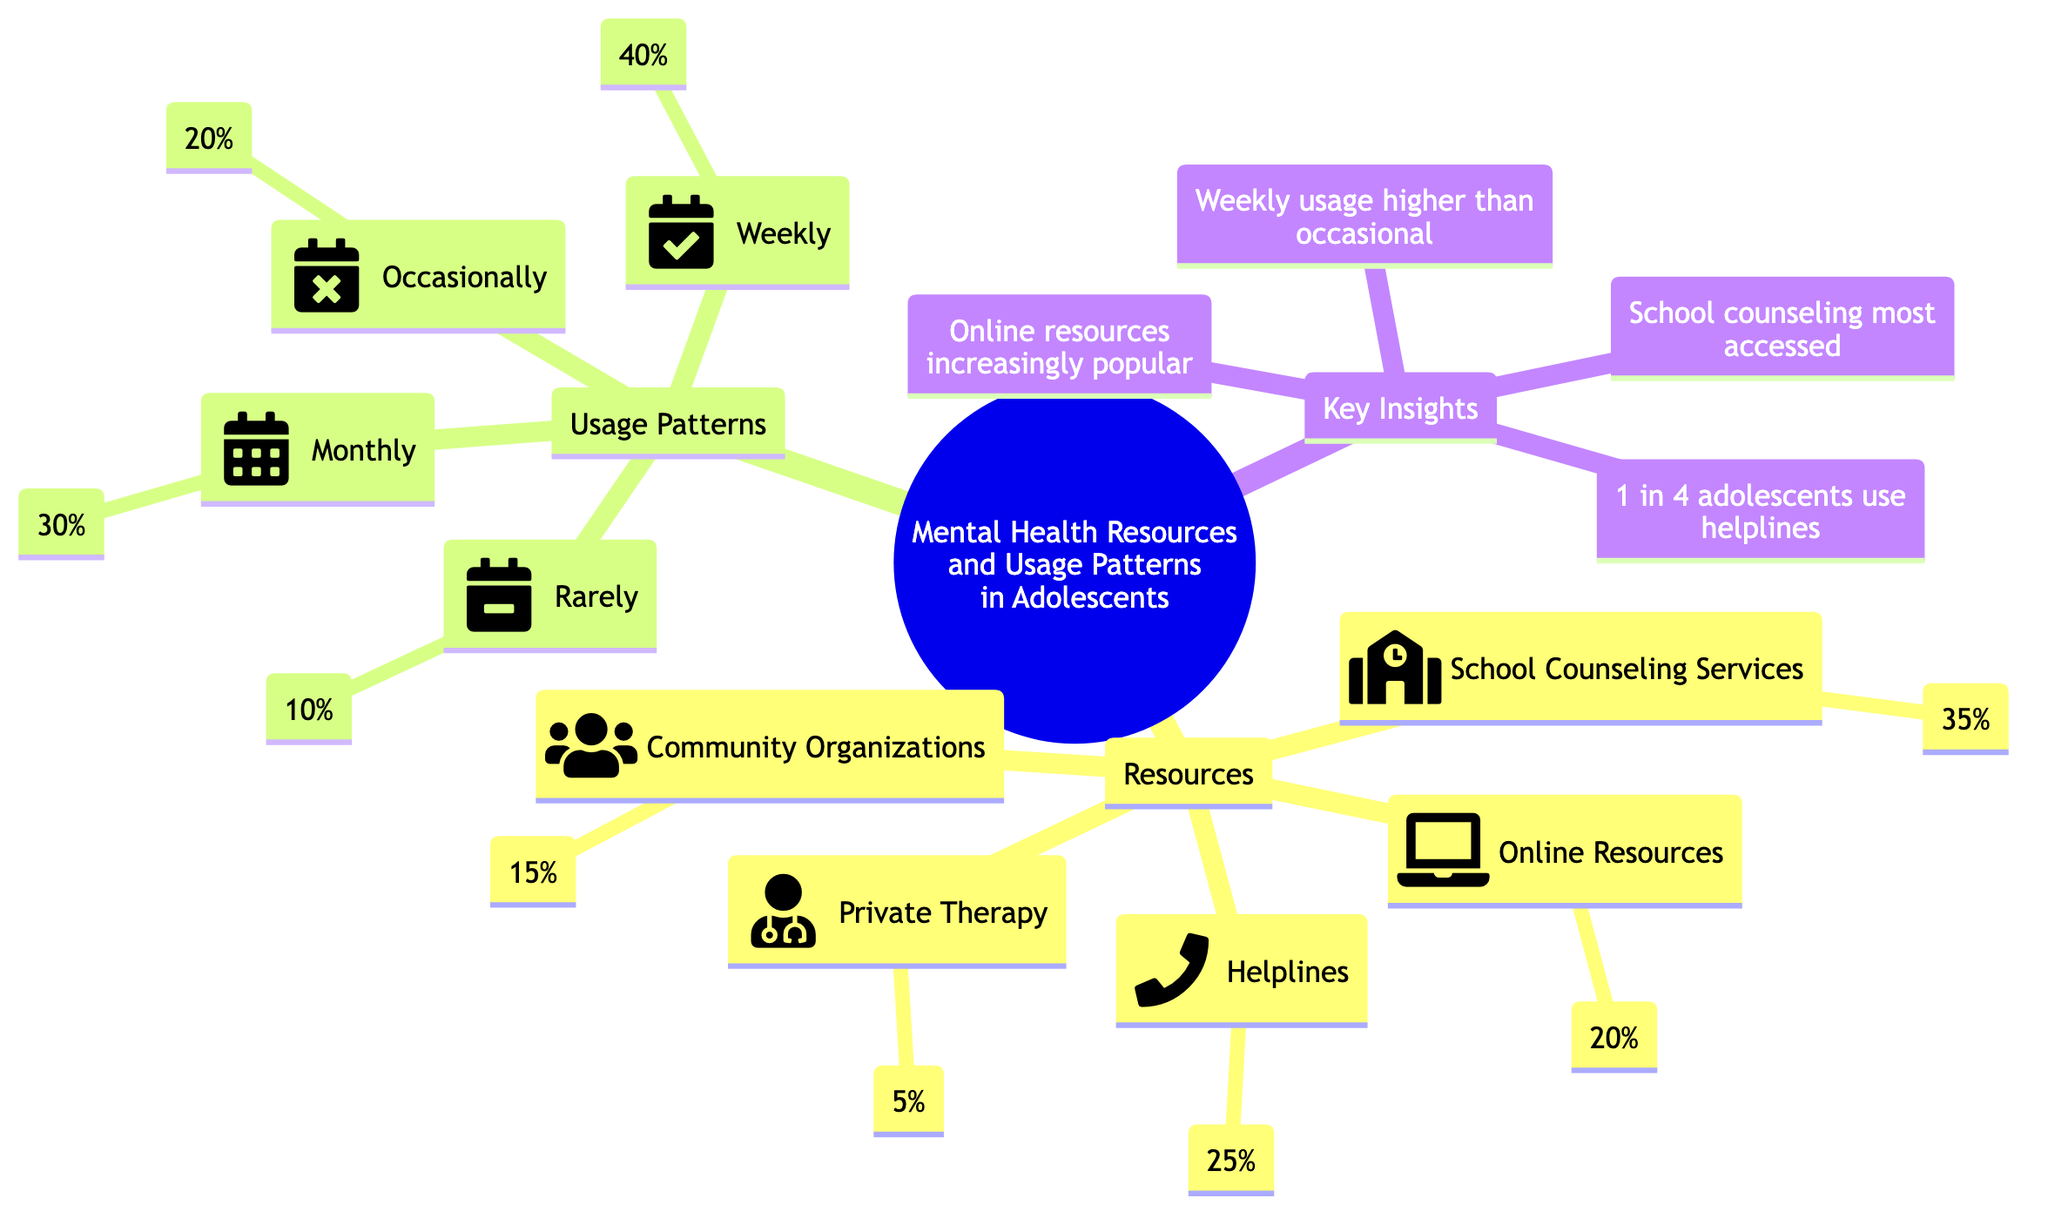What percentage of adolescents use school counseling services? The diagram shows that school counseling services account for 35% of the mental health resources used by adolescents. This percentage is directly stated in the diagram next to the "School Counseling Services" node.
Answer: 35% What is the least used mental health resource? The data indicates that private therapy has the lowest percentage of usage at 5%. This is found by comparing the values presented for each resource in the diagram.
Answer: 5% What proportion of adolescents use helplines regularly (weekly)? The infographic indicates that 40% of adolescents report using mental health resources on a weekly basis. This percentage is specified in the "Weekly" usage pattern node.
Answer: 40% Which resource is increasingly popular among adolescents? The diagram highlights that online resources are increasingly popular, explicitly stated in the "Key Insights" section. This reflects a trend in the data presented.
Answer: Online resources What percentage of adolescents engage with community organizations for mental health support? The diagram specifies that community organizations constitute 15% of the mental health resources utilized by adolescents. This figure is given next to the "Community Organizations" node.
Answer: 15% If 1 in 4 adolescents use helplines, what percentage does this represent? Since 1 in 4 translates to a fraction of 25%, this fact is presented as part of the key insights. The calculation is straightforward, dividing the total population by 4.
Answer: 25% What is the combined percentage of adolescents using online resources and private therapy? By adding the percentages of online resources (20%) and private therapy (5%), we find that together they account for 25% of the mental health resources used. This requires summing the relevant nodes.
Answer: 25% Which usage pattern has the lowest percentage? The diagram indicates that the "Rarely" usage pattern has the lowest percentage at 10%. This is directly noted in the respective usage pattern node.
Answer: 10% 